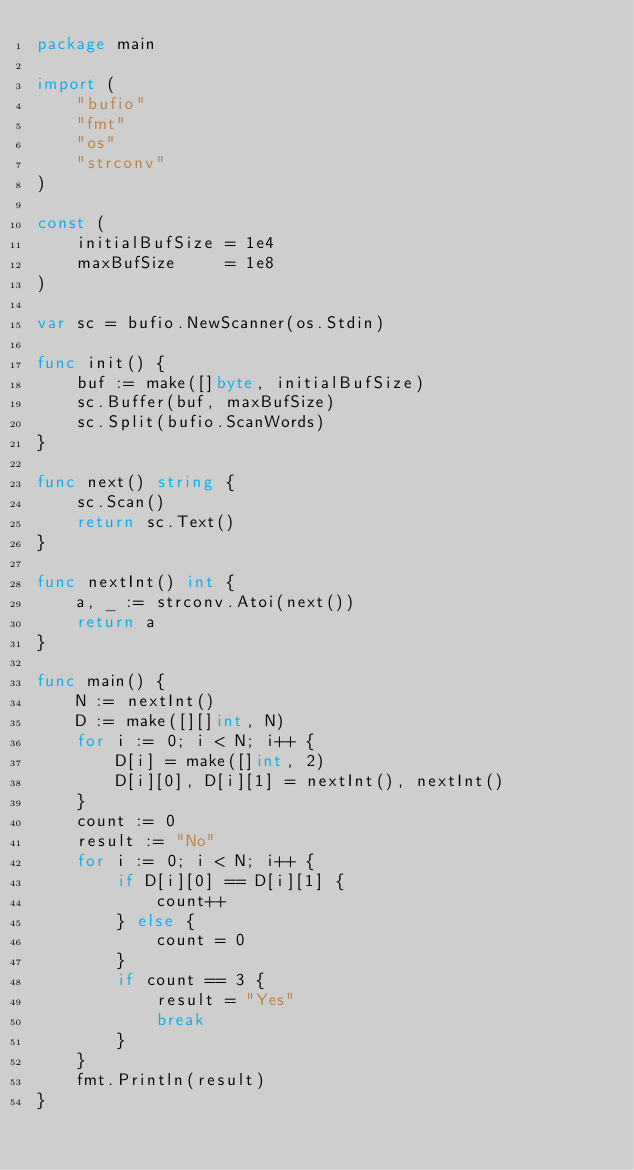Convert code to text. <code><loc_0><loc_0><loc_500><loc_500><_Go_>package main

import (
	"bufio"
	"fmt"
	"os"
	"strconv"
)

const (
	initialBufSize = 1e4
	maxBufSize     = 1e8
)

var sc = bufio.NewScanner(os.Stdin)

func init() {
	buf := make([]byte, initialBufSize)
	sc.Buffer(buf, maxBufSize)
	sc.Split(bufio.ScanWords)
}

func next() string {
	sc.Scan()
	return sc.Text()
}

func nextInt() int {
	a, _ := strconv.Atoi(next())
	return a
}

func main() {
	N := nextInt()
	D := make([][]int, N)
	for i := 0; i < N; i++ {
		D[i] = make([]int, 2)
		D[i][0], D[i][1] = nextInt(), nextInt()
	}
	count := 0
	result := "No"
	for i := 0; i < N; i++ {
		if D[i][0] == D[i][1] {
			count++
		} else {
			count = 0
		}
		if count == 3 {
			result = "Yes"
			break
		}
	}
	fmt.Println(result)
}
</code> 